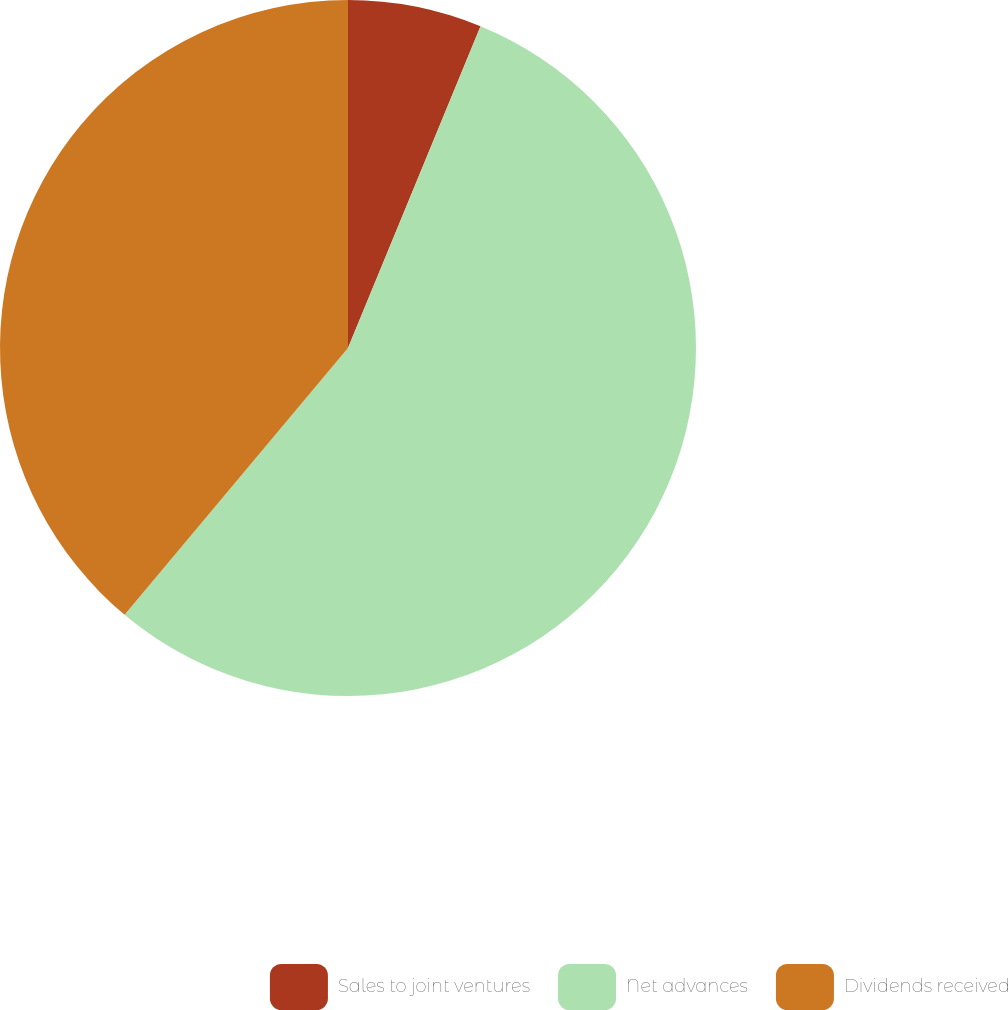<chart> <loc_0><loc_0><loc_500><loc_500><pie_chart><fcel>Sales to joint ventures<fcel>Net advances<fcel>Dividends received<nl><fcel>6.22%<fcel>54.88%<fcel>38.91%<nl></chart> 